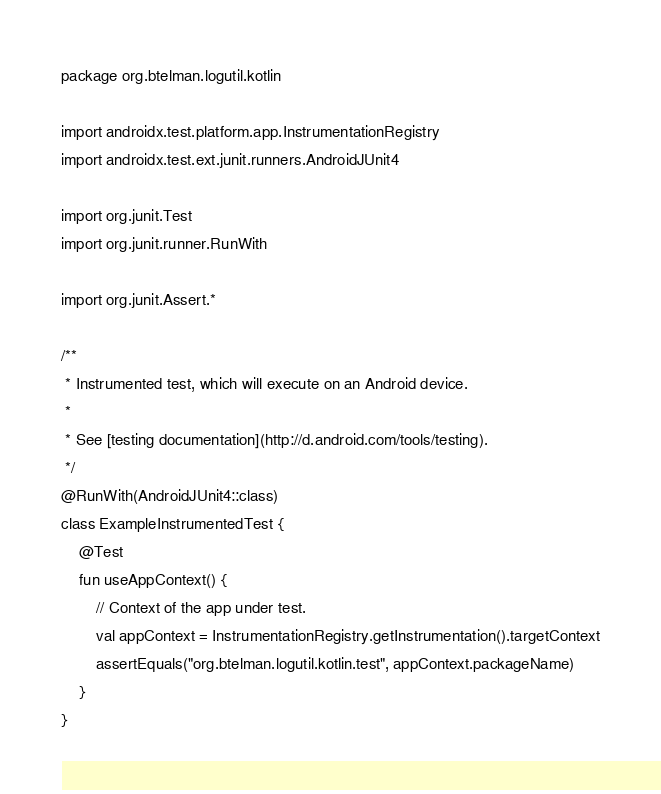<code> <loc_0><loc_0><loc_500><loc_500><_Kotlin_>package org.btelman.logutil.kotlin

import androidx.test.platform.app.InstrumentationRegistry
import androidx.test.ext.junit.runners.AndroidJUnit4

import org.junit.Test
import org.junit.runner.RunWith

import org.junit.Assert.*

/**
 * Instrumented test, which will execute on an Android device.
 *
 * See [testing documentation](http://d.android.com/tools/testing).
 */
@RunWith(AndroidJUnit4::class)
class ExampleInstrumentedTest {
    @Test
    fun useAppContext() {
        // Context of the app under test.
        val appContext = InstrumentationRegistry.getInstrumentation().targetContext
        assertEquals("org.btelman.logutil.kotlin.test", appContext.packageName)
    }
}
</code> 